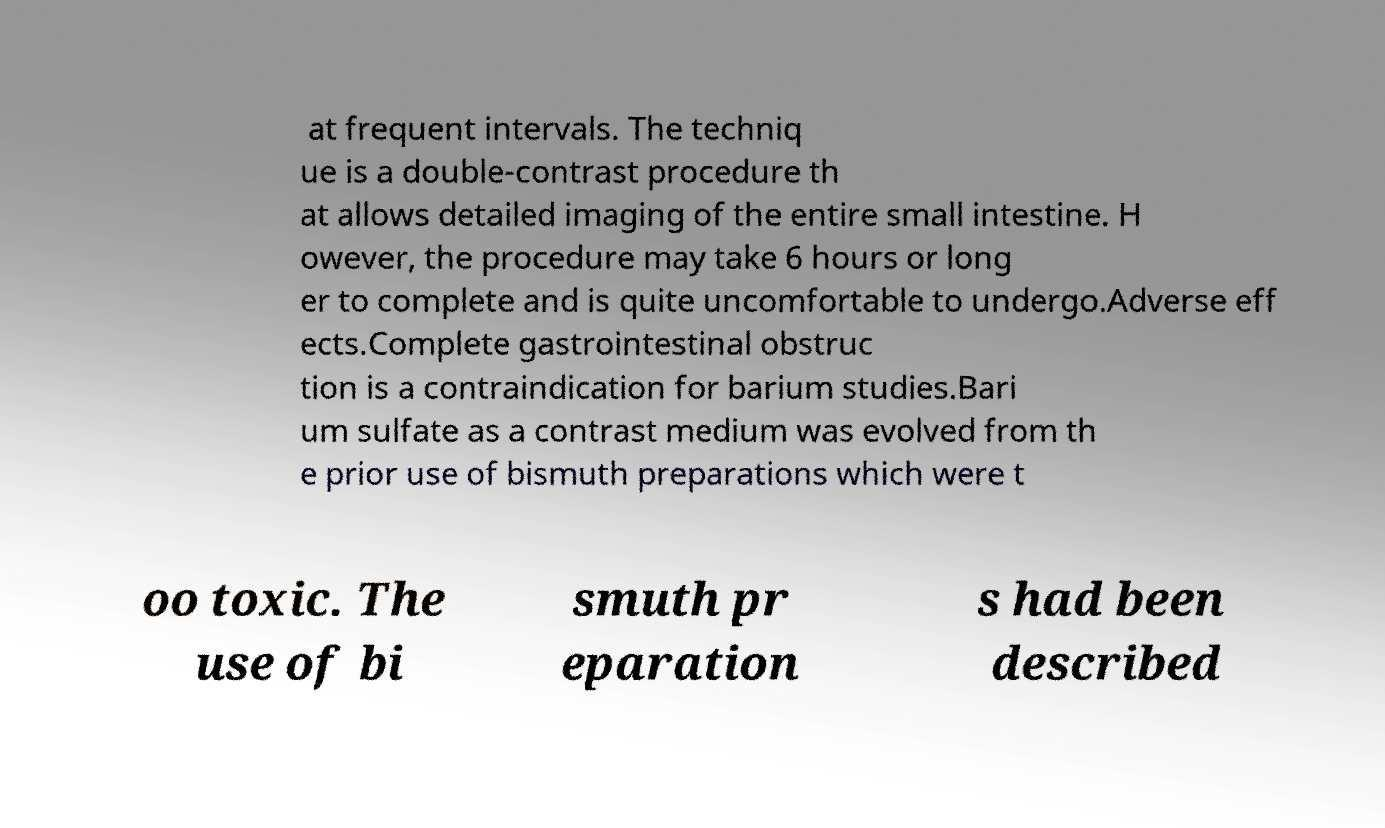Can you read and provide the text displayed in the image?This photo seems to have some interesting text. Can you extract and type it out for me? at frequent intervals. The techniq ue is a double-contrast procedure th at allows detailed imaging of the entire small intestine. H owever, the procedure may take 6 hours or long er to complete and is quite uncomfortable to undergo.Adverse eff ects.Complete gastrointestinal obstruc tion is a contraindication for barium studies.Bari um sulfate as a contrast medium was evolved from th e prior use of bismuth preparations which were t oo toxic. The use of bi smuth pr eparation s had been described 